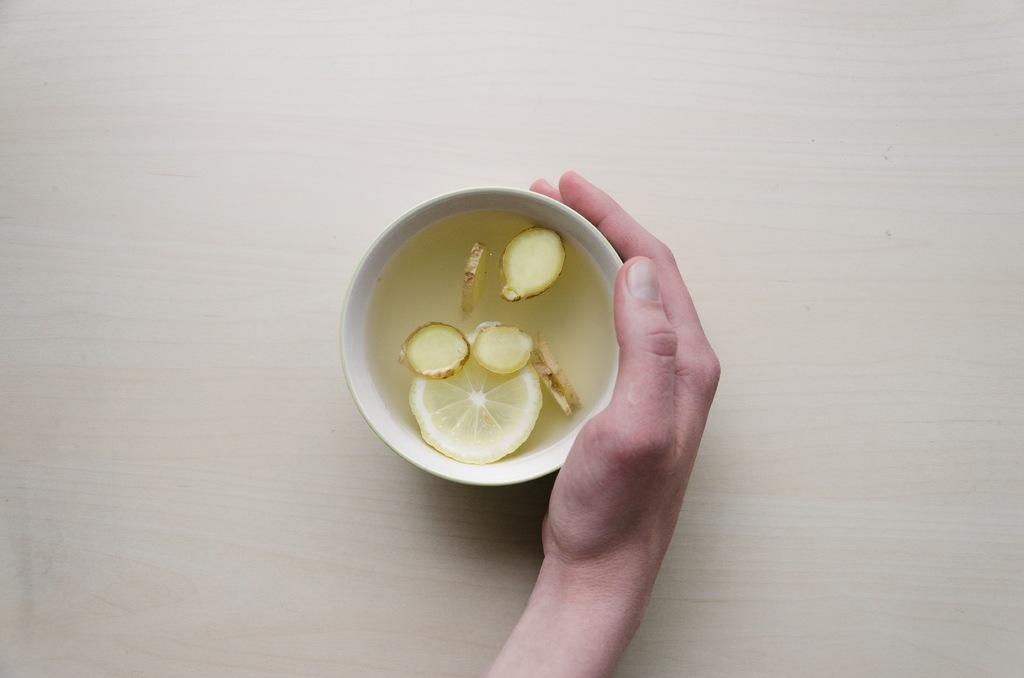What is the color and material of the surface in the image? The surface in the image is a cream-colored wooden plank. What is placed on the surface? There is a white-colored bowl on the surface. What is inside the bowl? The bowl contains liquid and lemon slices. Whose hand is holding the bowl? A person's hand is holding the bowl. What type of fruit can be seen growing in the cave in the image? There is no cave or fruit growing in the image; it features a cream-colored wooden plank surface with a white-colored bowl containing liquid and lemon slices. 